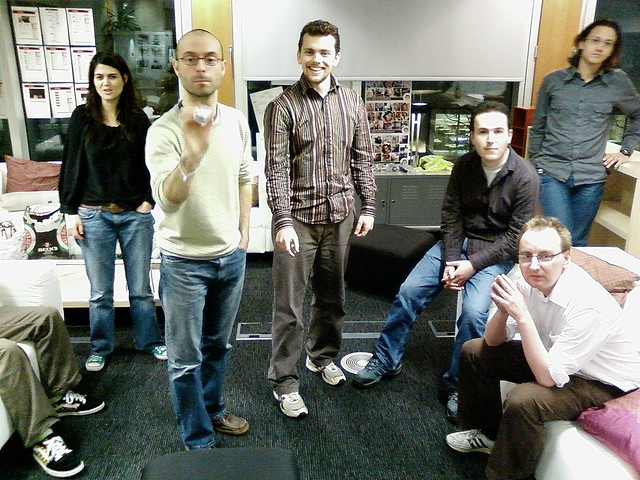Describe the objects in this image and their specific colors. I can see people in gray, black, white, and darkgray tones, people in gray, beige, black, and tan tones, people in gray, black, lightgray, and darkgray tones, people in gray, black, and blue tones, and people in gray, black, darkgreen, and darkgray tones in this image. 